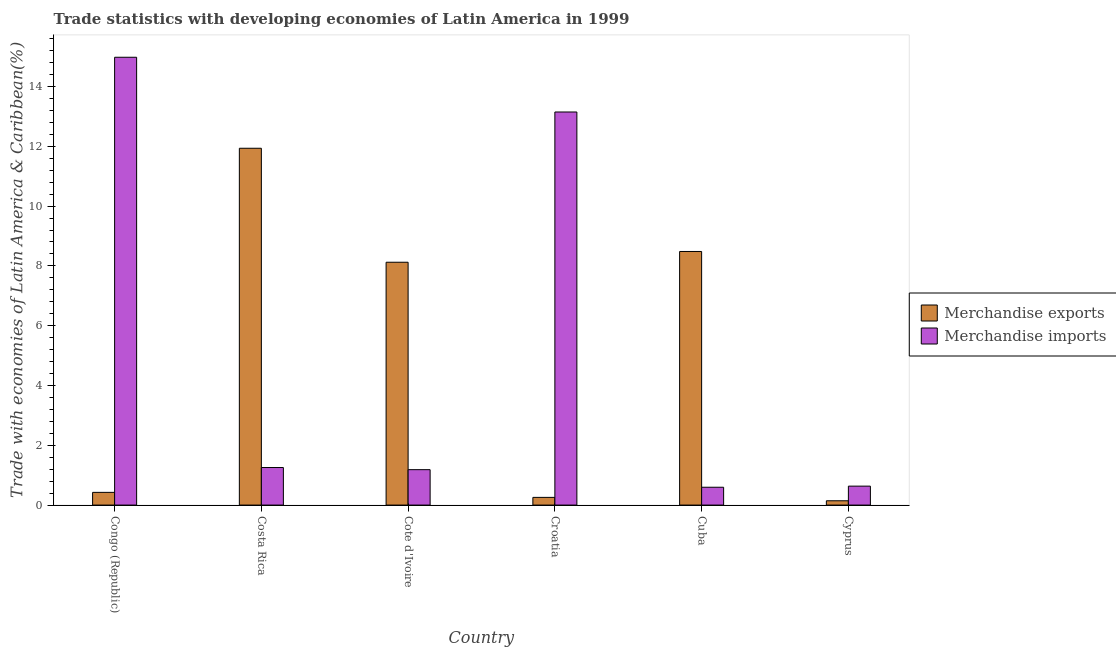How many groups of bars are there?
Offer a very short reply. 6. Are the number of bars on each tick of the X-axis equal?
Give a very brief answer. Yes. How many bars are there on the 2nd tick from the left?
Give a very brief answer. 2. In how many cases, is the number of bars for a given country not equal to the number of legend labels?
Your answer should be compact. 0. What is the merchandise exports in Croatia?
Your answer should be compact. 0.26. Across all countries, what is the maximum merchandise exports?
Offer a very short reply. 11.94. Across all countries, what is the minimum merchandise exports?
Give a very brief answer. 0.14. In which country was the merchandise imports minimum?
Ensure brevity in your answer.  Cuba. What is the total merchandise exports in the graph?
Provide a short and direct response. 29.37. What is the difference between the merchandise exports in Cote d'Ivoire and that in Cyprus?
Make the answer very short. 7.98. What is the difference between the merchandise exports in Croatia and the merchandise imports in Cuba?
Ensure brevity in your answer.  -0.34. What is the average merchandise exports per country?
Ensure brevity in your answer.  4.89. What is the difference between the merchandise exports and merchandise imports in Cote d'Ivoire?
Provide a succinct answer. 6.94. What is the ratio of the merchandise exports in Costa Rica to that in Cyprus?
Make the answer very short. 82.86. What is the difference between the highest and the second highest merchandise imports?
Keep it short and to the point. 1.83. What is the difference between the highest and the lowest merchandise imports?
Provide a succinct answer. 14.38. How many bars are there?
Give a very brief answer. 12. What is the difference between two consecutive major ticks on the Y-axis?
Keep it short and to the point. 2. Are the values on the major ticks of Y-axis written in scientific E-notation?
Provide a succinct answer. No. Does the graph contain any zero values?
Ensure brevity in your answer.  No. How are the legend labels stacked?
Offer a terse response. Vertical. What is the title of the graph?
Your answer should be compact. Trade statistics with developing economies of Latin America in 1999. What is the label or title of the Y-axis?
Provide a short and direct response. Trade with economies of Latin America & Caribbean(%). What is the Trade with economies of Latin America & Caribbean(%) of Merchandise exports in Congo (Republic)?
Offer a very short reply. 0.42. What is the Trade with economies of Latin America & Caribbean(%) in Merchandise imports in Congo (Republic)?
Make the answer very short. 14.98. What is the Trade with economies of Latin America & Caribbean(%) in Merchandise exports in Costa Rica?
Your answer should be very brief. 11.94. What is the Trade with economies of Latin America & Caribbean(%) of Merchandise imports in Costa Rica?
Give a very brief answer. 1.26. What is the Trade with economies of Latin America & Caribbean(%) in Merchandise exports in Cote d'Ivoire?
Keep it short and to the point. 8.12. What is the Trade with economies of Latin America & Caribbean(%) of Merchandise imports in Cote d'Ivoire?
Make the answer very short. 1.18. What is the Trade with economies of Latin America & Caribbean(%) of Merchandise exports in Croatia?
Give a very brief answer. 0.26. What is the Trade with economies of Latin America & Caribbean(%) of Merchandise imports in Croatia?
Give a very brief answer. 13.15. What is the Trade with economies of Latin America & Caribbean(%) of Merchandise exports in Cuba?
Offer a terse response. 8.48. What is the Trade with economies of Latin America & Caribbean(%) of Merchandise imports in Cuba?
Your answer should be compact. 0.6. What is the Trade with economies of Latin America & Caribbean(%) in Merchandise exports in Cyprus?
Offer a very short reply. 0.14. What is the Trade with economies of Latin America & Caribbean(%) in Merchandise imports in Cyprus?
Provide a succinct answer. 0.63. Across all countries, what is the maximum Trade with economies of Latin America & Caribbean(%) of Merchandise exports?
Your answer should be compact. 11.94. Across all countries, what is the maximum Trade with economies of Latin America & Caribbean(%) in Merchandise imports?
Your answer should be very brief. 14.98. Across all countries, what is the minimum Trade with economies of Latin America & Caribbean(%) of Merchandise exports?
Offer a very short reply. 0.14. Across all countries, what is the minimum Trade with economies of Latin America & Caribbean(%) of Merchandise imports?
Your answer should be compact. 0.6. What is the total Trade with economies of Latin America & Caribbean(%) of Merchandise exports in the graph?
Make the answer very short. 29.37. What is the total Trade with economies of Latin America & Caribbean(%) of Merchandise imports in the graph?
Your response must be concise. 31.8. What is the difference between the Trade with economies of Latin America & Caribbean(%) of Merchandise exports in Congo (Republic) and that in Costa Rica?
Offer a very short reply. -11.51. What is the difference between the Trade with economies of Latin America & Caribbean(%) in Merchandise imports in Congo (Republic) and that in Costa Rica?
Make the answer very short. 13.72. What is the difference between the Trade with economies of Latin America & Caribbean(%) of Merchandise exports in Congo (Republic) and that in Cote d'Ivoire?
Offer a terse response. -7.7. What is the difference between the Trade with economies of Latin America & Caribbean(%) in Merchandise imports in Congo (Republic) and that in Cote d'Ivoire?
Make the answer very short. 13.79. What is the difference between the Trade with economies of Latin America & Caribbean(%) in Merchandise exports in Congo (Republic) and that in Croatia?
Provide a succinct answer. 0.17. What is the difference between the Trade with economies of Latin America & Caribbean(%) of Merchandise imports in Congo (Republic) and that in Croatia?
Your answer should be very brief. 1.83. What is the difference between the Trade with economies of Latin America & Caribbean(%) in Merchandise exports in Congo (Republic) and that in Cuba?
Offer a terse response. -8.06. What is the difference between the Trade with economies of Latin America & Caribbean(%) of Merchandise imports in Congo (Republic) and that in Cuba?
Provide a short and direct response. 14.38. What is the difference between the Trade with economies of Latin America & Caribbean(%) in Merchandise exports in Congo (Republic) and that in Cyprus?
Ensure brevity in your answer.  0.28. What is the difference between the Trade with economies of Latin America & Caribbean(%) in Merchandise imports in Congo (Republic) and that in Cyprus?
Ensure brevity in your answer.  14.35. What is the difference between the Trade with economies of Latin America & Caribbean(%) in Merchandise exports in Costa Rica and that in Cote d'Ivoire?
Your answer should be compact. 3.81. What is the difference between the Trade with economies of Latin America & Caribbean(%) of Merchandise imports in Costa Rica and that in Cote d'Ivoire?
Ensure brevity in your answer.  0.07. What is the difference between the Trade with economies of Latin America & Caribbean(%) in Merchandise exports in Costa Rica and that in Croatia?
Provide a succinct answer. 11.68. What is the difference between the Trade with economies of Latin America & Caribbean(%) in Merchandise imports in Costa Rica and that in Croatia?
Your answer should be very brief. -11.89. What is the difference between the Trade with economies of Latin America & Caribbean(%) in Merchandise exports in Costa Rica and that in Cuba?
Provide a succinct answer. 3.45. What is the difference between the Trade with economies of Latin America & Caribbean(%) of Merchandise imports in Costa Rica and that in Cuba?
Your response must be concise. 0.66. What is the difference between the Trade with economies of Latin America & Caribbean(%) in Merchandise exports in Costa Rica and that in Cyprus?
Ensure brevity in your answer.  11.79. What is the difference between the Trade with economies of Latin America & Caribbean(%) in Merchandise imports in Costa Rica and that in Cyprus?
Give a very brief answer. 0.62. What is the difference between the Trade with economies of Latin America & Caribbean(%) in Merchandise exports in Cote d'Ivoire and that in Croatia?
Make the answer very short. 7.87. What is the difference between the Trade with economies of Latin America & Caribbean(%) of Merchandise imports in Cote d'Ivoire and that in Croatia?
Your answer should be compact. -11.96. What is the difference between the Trade with economies of Latin America & Caribbean(%) of Merchandise exports in Cote d'Ivoire and that in Cuba?
Ensure brevity in your answer.  -0.36. What is the difference between the Trade with economies of Latin America & Caribbean(%) in Merchandise imports in Cote d'Ivoire and that in Cuba?
Ensure brevity in your answer.  0.59. What is the difference between the Trade with economies of Latin America & Caribbean(%) of Merchandise exports in Cote d'Ivoire and that in Cyprus?
Offer a terse response. 7.98. What is the difference between the Trade with economies of Latin America & Caribbean(%) of Merchandise imports in Cote d'Ivoire and that in Cyprus?
Your answer should be compact. 0.55. What is the difference between the Trade with economies of Latin America & Caribbean(%) of Merchandise exports in Croatia and that in Cuba?
Make the answer very short. -8.23. What is the difference between the Trade with economies of Latin America & Caribbean(%) of Merchandise imports in Croatia and that in Cuba?
Provide a succinct answer. 12.55. What is the difference between the Trade with economies of Latin America & Caribbean(%) in Merchandise exports in Croatia and that in Cyprus?
Give a very brief answer. 0.11. What is the difference between the Trade with economies of Latin America & Caribbean(%) of Merchandise imports in Croatia and that in Cyprus?
Offer a very short reply. 12.52. What is the difference between the Trade with economies of Latin America & Caribbean(%) of Merchandise exports in Cuba and that in Cyprus?
Your answer should be compact. 8.34. What is the difference between the Trade with economies of Latin America & Caribbean(%) of Merchandise imports in Cuba and that in Cyprus?
Give a very brief answer. -0.04. What is the difference between the Trade with economies of Latin America & Caribbean(%) in Merchandise exports in Congo (Republic) and the Trade with economies of Latin America & Caribbean(%) in Merchandise imports in Costa Rica?
Offer a very short reply. -0.83. What is the difference between the Trade with economies of Latin America & Caribbean(%) of Merchandise exports in Congo (Republic) and the Trade with economies of Latin America & Caribbean(%) of Merchandise imports in Cote d'Ivoire?
Make the answer very short. -0.76. What is the difference between the Trade with economies of Latin America & Caribbean(%) of Merchandise exports in Congo (Republic) and the Trade with economies of Latin America & Caribbean(%) of Merchandise imports in Croatia?
Ensure brevity in your answer.  -12.72. What is the difference between the Trade with economies of Latin America & Caribbean(%) of Merchandise exports in Congo (Republic) and the Trade with economies of Latin America & Caribbean(%) of Merchandise imports in Cuba?
Your answer should be compact. -0.17. What is the difference between the Trade with economies of Latin America & Caribbean(%) of Merchandise exports in Congo (Republic) and the Trade with economies of Latin America & Caribbean(%) of Merchandise imports in Cyprus?
Keep it short and to the point. -0.21. What is the difference between the Trade with economies of Latin America & Caribbean(%) of Merchandise exports in Costa Rica and the Trade with economies of Latin America & Caribbean(%) of Merchandise imports in Cote d'Ivoire?
Your answer should be compact. 10.75. What is the difference between the Trade with economies of Latin America & Caribbean(%) of Merchandise exports in Costa Rica and the Trade with economies of Latin America & Caribbean(%) of Merchandise imports in Croatia?
Make the answer very short. -1.21. What is the difference between the Trade with economies of Latin America & Caribbean(%) of Merchandise exports in Costa Rica and the Trade with economies of Latin America & Caribbean(%) of Merchandise imports in Cuba?
Provide a short and direct response. 11.34. What is the difference between the Trade with economies of Latin America & Caribbean(%) in Merchandise exports in Costa Rica and the Trade with economies of Latin America & Caribbean(%) in Merchandise imports in Cyprus?
Give a very brief answer. 11.3. What is the difference between the Trade with economies of Latin America & Caribbean(%) of Merchandise exports in Cote d'Ivoire and the Trade with economies of Latin America & Caribbean(%) of Merchandise imports in Croatia?
Ensure brevity in your answer.  -5.03. What is the difference between the Trade with economies of Latin America & Caribbean(%) in Merchandise exports in Cote d'Ivoire and the Trade with economies of Latin America & Caribbean(%) in Merchandise imports in Cuba?
Your response must be concise. 7.53. What is the difference between the Trade with economies of Latin America & Caribbean(%) in Merchandise exports in Cote d'Ivoire and the Trade with economies of Latin America & Caribbean(%) in Merchandise imports in Cyprus?
Your response must be concise. 7.49. What is the difference between the Trade with economies of Latin America & Caribbean(%) in Merchandise exports in Croatia and the Trade with economies of Latin America & Caribbean(%) in Merchandise imports in Cuba?
Offer a terse response. -0.34. What is the difference between the Trade with economies of Latin America & Caribbean(%) of Merchandise exports in Croatia and the Trade with economies of Latin America & Caribbean(%) of Merchandise imports in Cyprus?
Give a very brief answer. -0.38. What is the difference between the Trade with economies of Latin America & Caribbean(%) of Merchandise exports in Cuba and the Trade with economies of Latin America & Caribbean(%) of Merchandise imports in Cyprus?
Give a very brief answer. 7.85. What is the average Trade with economies of Latin America & Caribbean(%) of Merchandise exports per country?
Your answer should be very brief. 4.89. What is the average Trade with economies of Latin America & Caribbean(%) in Merchandise imports per country?
Offer a terse response. 5.3. What is the difference between the Trade with economies of Latin America & Caribbean(%) of Merchandise exports and Trade with economies of Latin America & Caribbean(%) of Merchandise imports in Congo (Republic)?
Provide a succinct answer. -14.55. What is the difference between the Trade with economies of Latin America & Caribbean(%) in Merchandise exports and Trade with economies of Latin America & Caribbean(%) in Merchandise imports in Costa Rica?
Make the answer very short. 10.68. What is the difference between the Trade with economies of Latin America & Caribbean(%) of Merchandise exports and Trade with economies of Latin America & Caribbean(%) of Merchandise imports in Cote d'Ivoire?
Make the answer very short. 6.94. What is the difference between the Trade with economies of Latin America & Caribbean(%) of Merchandise exports and Trade with economies of Latin America & Caribbean(%) of Merchandise imports in Croatia?
Offer a very short reply. -12.89. What is the difference between the Trade with economies of Latin America & Caribbean(%) in Merchandise exports and Trade with economies of Latin America & Caribbean(%) in Merchandise imports in Cuba?
Your answer should be very brief. 7.89. What is the difference between the Trade with economies of Latin America & Caribbean(%) in Merchandise exports and Trade with economies of Latin America & Caribbean(%) in Merchandise imports in Cyprus?
Your answer should be very brief. -0.49. What is the ratio of the Trade with economies of Latin America & Caribbean(%) of Merchandise exports in Congo (Republic) to that in Costa Rica?
Offer a terse response. 0.04. What is the ratio of the Trade with economies of Latin America & Caribbean(%) of Merchandise imports in Congo (Republic) to that in Costa Rica?
Your answer should be very brief. 11.93. What is the ratio of the Trade with economies of Latin America & Caribbean(%) of Merchandise exports in Congo (Republic) to that in Cote d'Ivoire?
Ensure brevity in your answer.  0.05. What is the ratio of the Trade with economies of Latin America & Caribbean(%) in Merchandise imports in Congo (Republic) to that in Cote d'Ivoire?
Make the answer very short. 12.65. What is the ratio of the Trade with economies of Latin America & Caribbean(%) of Merchandise exports in Congo (Republic) to that in Croatia?
Your answer should be compact. 1.65. What is the ratio of the Trade with economies of Latin America & Caribbean(%) in Merchandise imports in Congo (Republic) to that in Croatia?
Your answer should be very brief. 1.14. What is the ratio of the Trade with economies of Latin America & Caribbean(%) of Merchandise exports in Congo (Republic) to that in Cuba?
Your answer should be very brief. 0.05. What is the ratio of the Trade with economies of Latin America & Caribbean(%) of Merchandise imports in Congo (Republic) to that in Cuba?
Ensure brevity in your answer.  25.1. What is the ratio of the Trade with economies of Latin America & Caribbean(%) in Merchandise exports in Congo (Republic) to that in Cyprus?
Your response must be concise. 2.95. What is the ratio of the Trade with economies of Latin America & Caribbean(%) of Merchandise imports in Congo (Republic) to that in Cyprus?
Ensure brevity in your answer.  23.65. What is the ratio of the Trade with economies of Latin America & Caribbean(%) in Merchandise exports in Costa Rica to that in Cote d'Ivoire?
Your answer should be compact. 1.47. What is the ratio of the Trade with economies of Latin America & Caribbean(%) of Merchandise imports in Costa Rica to that in Cote d'Ivoire?
Offer a very short reply. 1.06. What is the ratio of the Trade with economies of Latin America & Caribbean(%) in Merchandise exports in Costa Rica to that in Croatia?
Offer a terse response. 46.45. What is the ratio of the Trade with economies of Latin America & Caribbean(%) of Merchandise imports in Costa Rica to that in Croatia?
Offer a terse response. 0.1. What is the ratio of the Trade with economies of Latin America & Caribbean(%) of Merchandise exports in Costa Rica to that in Cuba?
Keep it short and to the point. 1.41. What is the ratio of the Trade with economies of Latin America & Caribbean(%) in Merchandise imports in Costa Rica to that in Cuba?
Make the answer very short. 2.1. What is the ratio of the Trade with economies of Latin America & Caribbean(%) of Merchandise exports in Costa Rica to that in Cyprus?
Your answer should be very brief. 82.86. What is the ratio of the Trade with economies of Latin America & Caribbean(%) of Merchandise imports in Costa Rica to that in Cyprus?
Make the answer very short. 1.98. What is the ratio of the Trade with economies of Latin America & Caribbean(%) in Merchandise exports in Cote d'Ivoire to that in Croatia?
Provide a succinct answer. 31.61. What is the ratio of the Trade with economies of Latin America & Caribbean(%) of Merchandise imports in Cote d'Ivoire to that in Croatia?
Keep it short and to the point. 0.09. What is the ratio of the Trade with economies of Latin America & Caribbean(%) in Merchandise exports in Cote d'Ivoire to that in Cuba?
Your answer should be compact. 0.96. What is the ratio of the Trade with economies of Latin America & Caribbean(%) of Merchandise imports in Cote d'Ivoire to that in Cuba?
Your response must be concise. 1.99. What is the ratio of the Trade with economies of Latin America & Caribbean(%) of Merchandise exports in Cote d'Ivoire to that in Cyprus?
Your response must be concise. 56.39. What is the ratio of the Trade with economies of Latin America & Caribbean(%) in Merchandise imports in Cote d'Ivoire to that in Cyprus?
Offer a terse response. 1.87. What is the ratio of the Trade with economies of Latin America & Caribbean(%) in Merchandise exports in Croatia to that in Cuba?
Ensure brevity in your answer.  0.03. What is the ratio of the Trade with economies of Latin America & Caribbean(%) in Merchandise imports in Croatia to that in Cuba?
Your answer should be compact. 22.04. What is the ratio of the Trade with economies of Latin America & Caribbean(%) in Merchandise exports in Croatia to that in Cyprus?
Provide a succinct answer. 1.78. What is the ratio of the Trade with economies of Latin America & Caribbean(%) of Merchandise imports in Croatia to that in Cyprus?
Your answer should be very brief. 20.76. What is the ratio of the Trade with economies of Latin America & Caribbean(%) in Merchandise exports in Cuba to that in Cyprus?
Make the answer very short. 58.89. What is the ratio of the Trade with economies of Latin America & Caribbean(%) of Merchandise imports in Cuba to that in Cyprus?
Offer a terse response. 0.94. What is the difference between the highest and the second highest Trade with economies of Latin America & Caribbean(%) in Merchandise exports?
Offer a terse response. 3.45. What is the difference between the highest and the second highest Trade with economies of Latin America & Caribbean(%) of Merchandise imports?
Make the answer very short. 1.83. What is the difference between the highest and the lowest Trade with economies of Latin America & Caribbean(%) of Merchandise exports?
Ensure brevity in your answer.  11.79. What is the difference between the highest and the lowest Trade with economies of Latin America & Caribbean(%) of Merchandise imports?
Your answer should be very brief. 14.38. 